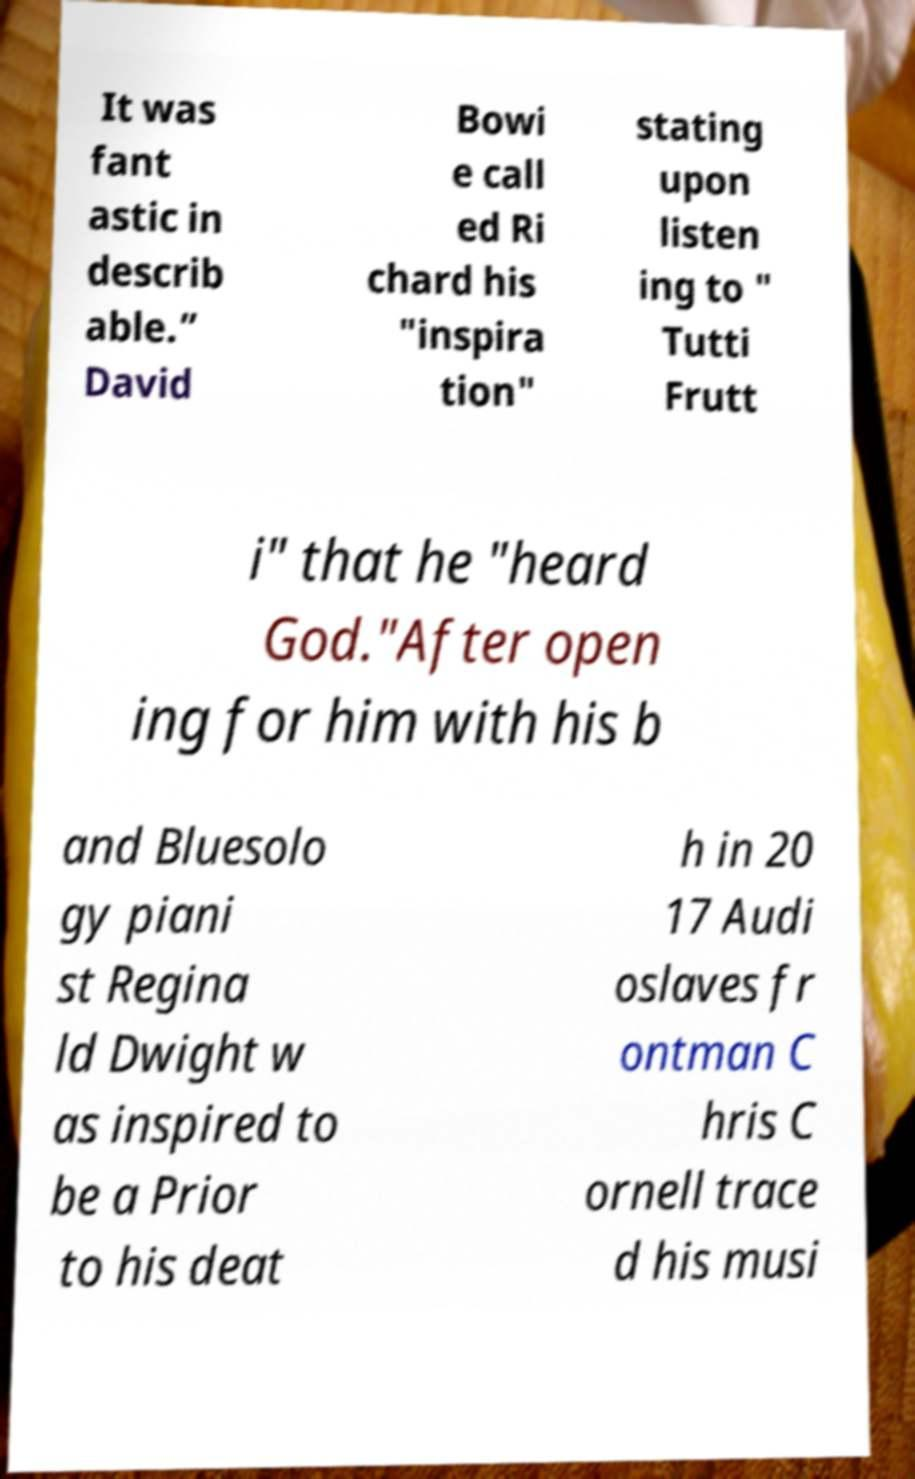I need the written content from this picture converted into text. Can you do that? It was fant astic in describ able.” David Bowi e call ed Ri chard his "inspira tion" stating upon listen ing to " Tutti Frutt i" that he "heard God."After open ing for him with his b and Bluesolo gy piani st Regina ld Dwight w as inspired to be a Prior to his deat h in 20 17 Audi oslaves fr ontman C hris C ornell trace d his musi 